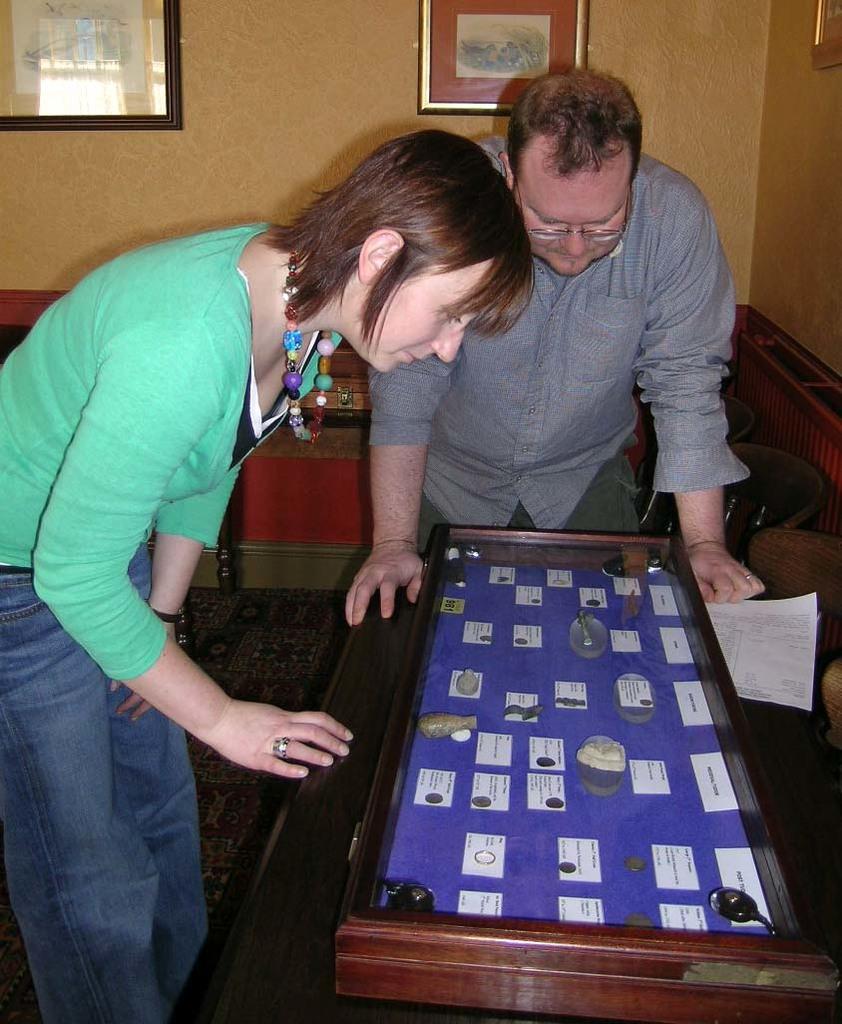Can you describe this image briefly? In this image I can see two people. Among them one person is is wearing the green color dress and another one is with grey color. In front of them there is a box with blue color. In side box there are papers attached. In the background there are frames attached to the wall. 